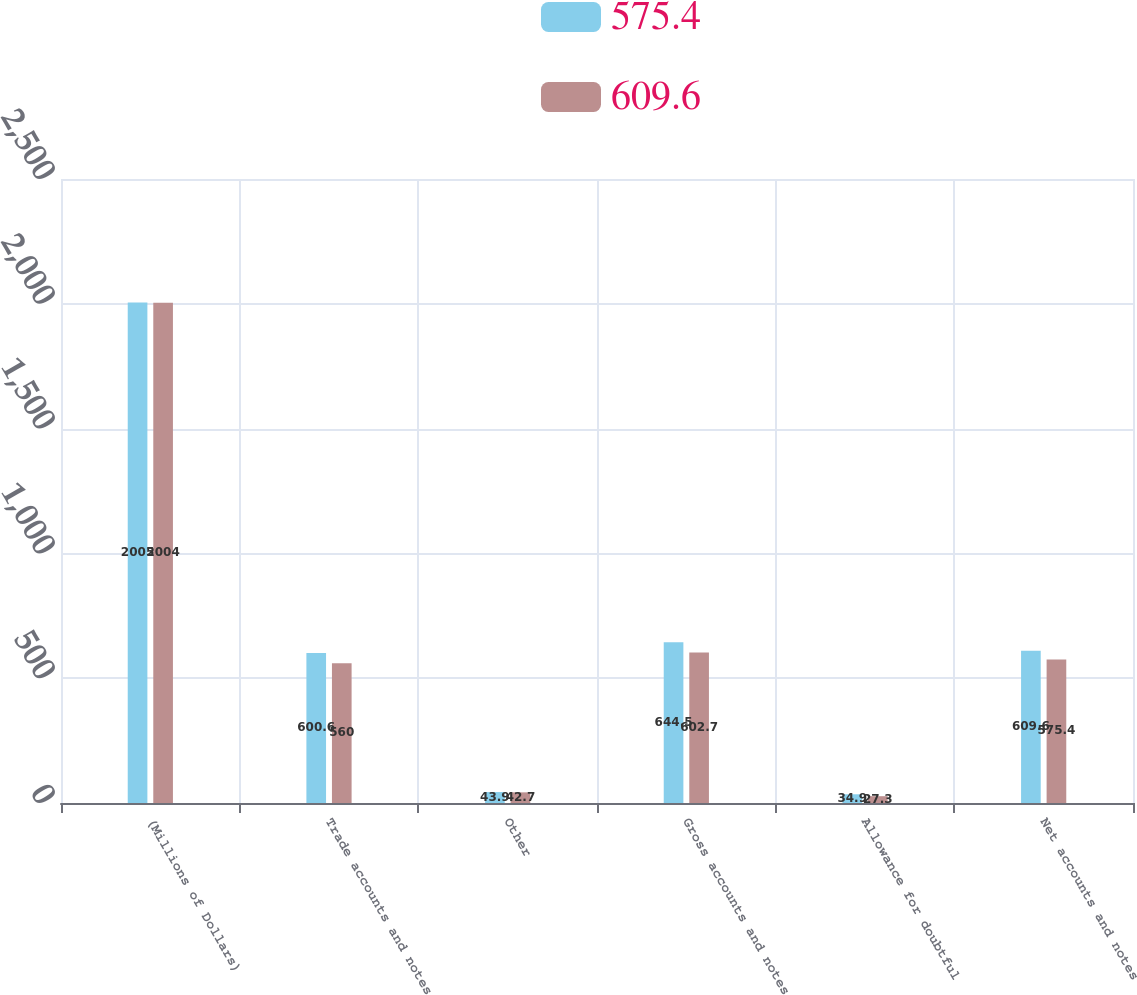Convert chart to OTSL. <chart><loc_0><loc_0><loc_500><loc_500><stacked_bar_chart><ecel><fcel>(Millions of Dollars)<fcel>Trade accounts and notes<fcel>Other<fcel>Gross accounts and notes<fcel>Allowance for doubtful<fcel>Net accounts and notes<nl><fcel>575.4<fcel>2005<fcel>600.6<fcel>43.9<fcel>644.5<fcel>34.9<fcel>609.6<nl><fcel>609.6<fcel>2004<fcel>560<fcel>42.7<fcel>602.7<fcel>27.3<fcel>575.4<nl></chart> 